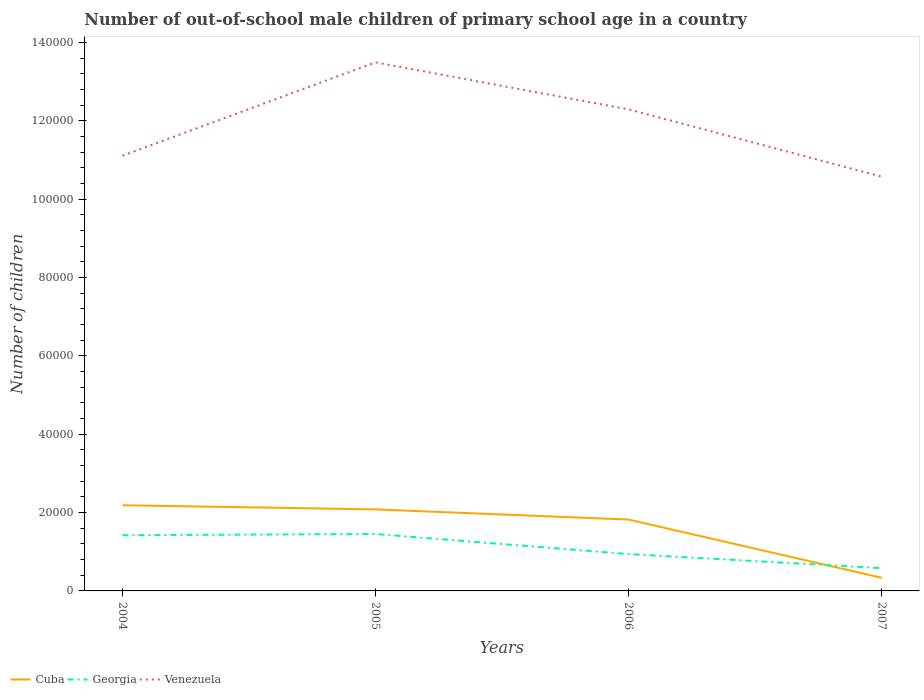Across all years, what is the maximum number of out-of-school male children in Venezuela?
Your answer should be very brief. 1.06e+05. In which year was the number of out-of-school male children in Georgia maximum?
Provide a short and direct response. 2007. What is the total number of out-of-school male children in Venezuela in the graph?
Provide a short and direct response. 1.72e+04. What is the difference between the highest and the second highest number of out-of-school male children in Cuba?
Keep it short and to the point. 1.85e+04. How many years are there in the graph?
Provide a succinct answer. 4. What is the difference between two consecutive major ticks on the Y-axis?
Make the answer very short. 2.00e+04. Does the graph contain any zero values?
Give a very brief answer. No. Does the graph contain grids?
Offer a terse response. No. How many legend labels are there?
Provide a succinct answer. 3. What is the title of the graph?
Keep it short and to the point. Number of out-of-school male children of primary school age in a country. What is the label or title of the X-axis?
Keep it short and to the point. Years. What is the label or title of the Y-axis?
Keep it short and to the point. Number of children. What is the Number of children of Cuba in 2004?
Give a very brief answer. 2.19e+04. What is the Number of children of Georgia in 2004?
Give a very brief answer. 1.42e+04. What is the Number of children in Venezuela in 2004?
Offer a terse response. 1.11e+05. What is the Number of children in Cuba in 2005?
Offer a terse response. 2.08e+04. What is the Number of children in Georgia in 2005?
Make the answer very short. 1.45e+04. What is the Number of children of Venezuela in 2005?
Your response must be concise. 1.35e+05. What is the Number of children of Cuba in 2006?
Offer a very short reply. 1.82e+04. What is the Number of children in Georgia in 2006?
Make the answer very short. 9409. What is the Number of children of Venezuela in 2006?
Make the answer very short. 1.23e+05. What is the Number of children of Cuba in 2007?
Your answer should be very brief. 3360. What is the Number of children of Georgia in 2007?
Make the answer very short. 5818. What is the Number of children of Venezuela in 2007?
Offer a terse response. 1.06e+05. Across all years, what is the maximum Number of children of Cuba?
Your answer should be very brief. 2.19e+04. Across all years, what is the maximum Number of children in Georgia?
Keep it short and to the point. 1.45e+04. Across all years, what is the maximum Number of children of Venezuela?
Make the answer very short. 1.35e+05. Across all years, what is the minimum Number of children in Cuba?
Provide a succinct answer. 3360. Across all years, what is the minimum Number of children in Georgia?
Provide a succinct answer. 5818. Across all years, what is the minimum Number of children in Venezuela?
Offer a very short reply. 1.06e+05. What is the total Number of children of Cuba in the graph?
Your response must be concise. 6.43e+04. What is the total Number of children in Georgia in the graph?
Make the answer very short. 4.40e+04. What is the total Number of children in Venezuela in the graph?
Provide a succinct answer. 4.75e+05. What is the difference between the Number of children of Cuba in 2004 and that in 2005?
Provide a short and direct response. 1065. What is the difference between the Number of children of Georgia in 2004 and that in 2005?
Provide a succinct answer. -311. What is the difference between the Number of children in Venezuela in 2004 and that in 2005?
Make the answer very short. -2.38e+04. What is the difference between the Number of children in Cuba in 2004 and that in 2006?
Keep it short and to the point. 3655. What is the difference between the Number of children in Georgia in 2004 and that in 2006?
Your response must be concise. 4809. What is the difference between the Number of children of Venezuela in 2004 and that in 2006?
Provide a succinct answer. -1.18e+04. What is the difference between the Number of children in Cuba in 2004 and that in 2007?
Offer a terse response. 1.85e+04. What is the difference between the Number of children of Georgia in 2004 and that in 2007?
Provide a short and direct response. 8400. What is the difference between the Number of children in Venezuela in 2004 and that in 2007?
Give a very brief answer. 5335. What is the difference between the Number of children of Cuba in 2005 and that in 2006?
Offer a terse response. 2590. What is the difference between the Number of children in Georgia in 2005 and that in 2006?
Your response must be concise. 5120. What is the difference between the Number of children in Venezuela in 2005 and that in 2006?
Ensure brevity in your answer.  1.20e+04. What is the difference between the Number of children of Cuba in 2005 and that in 2007?
Give a very brief answer. 1.74e+04. What is the difference between the Number of children in Georgia in 2005 and that in 2007?
Give a very brief answer. 8711. What is the difference between the Number of children of Venezuela in 2005 and that in 2007?
Offer a very short reply. 2.92e+04. What is the difference between the Number of children of Cuba in 2006 and that in 2007?
Provide a short and direct response. 1.49e+04. What is the difference between the Number of children of Georgia in 2006 and that in 2007?
Ensure brevity in your answer.  3591. What is the difference between the Number of children in Venezuela in 2006 and that in 2007?
Offer a terse response. 1.72e+04. What is the difference between the Number of children in Cuba in 2004 and the Number of children in Georgia in 2005?
Your answer should be very brief. 7345. What is the difference between the Number of children in Cuba in 2004 and the Number of children in Venezuela in 2005?
Your answer should be compact. -1.13e+05. What is the difference between the Number of children of Georgia in 2004 and the Number of children of Venezuela in 2005?
Keep it short and to the point. -1.21e+05. What is the difference between the Number of children in Cuba in 2004 and the Number of children in Georgia in 2006?
Offer a terse response. 1.25e+04. What is the difference between the Number of children in Cuba in 2004 and the Number of children in Venezuela in 2006?
Your answer should be very brief. -1.01e+05. What is the difference between the Number of children in Georgia in 2004 and the Number of children in Venezuela in 2006?
Provide a short and direct response. -1.09e+05. What is the difference between the Number of children of Cuba in 2004 and the Number of children of Georgia in 2007?
Make the answer very short. 1.61e+04. What is the difference between the Number of children in Cuba in 2004 and the Number of children in Venezuela in 2007?
Ensure brevity in your answer.  -8.39e+04. What is the difference between the Number of children in Georgia in 2004 and the Number of children in Venezuela in 2007?
Make the answer very short. -9.15e+04. What is the difference between the Number of children in Cuba in 2005 and the Number of children in Georgia in 2006?
Provide a short and direct response. 1.14e+04. What is the difference between the Number of children of Cuba in 2005 and the Number of children of Venezuela in 2006?
Keep it short and to the point. -1.02e+05. What is the difference between the Number of children of Georgia in 2005 and the Number of children of Venezuela in 2006?
Make the answer very short. -1.08e+05. What is the difference between the Number of children of Cuba in 2005 and the Number of children of Georgia in 2007?
Ensure brevity in your answer.  1.50e+04. What is the difference between the Number of children of Cuba in 2005 and the Number of children of Venezuela in 2007?
Your response must be concise. -8.49e+04. What is the difference between the Number of children of Georgia in 2005 and the Number of children of Venezuela in 2007?
Your answer should be compact. -9.12e+04. What is the difference between the Number of children in Cuba in 2006 and the Number of children in Georgia in 2007?
Make the answer very short. 1.24e+04. What is the difference between the Number of children in Cuba in 2006 and the Number of children in Venezuela in 2007?
Make the answer very short. -8.75e+04. What is the difference between the Number of children of Georgia in 2006 and the Number of children of Venezuela in 2007?
Offer a terse response. -9.63e+04. What is the average Number of children in Cuba per year?
Keep it short and to the point. 1.61e+04. What is the average Number of children of Georgia per year?
Provide a short and direct response. 1.10e+04. What is the average Number of children in Venezuela per year?
Your response must be concise. 1.19e+05. In the year 2004, what is the difference between the Number of children of Cuba and Number of children of Georgia?
Offer a very short reply. 7656. In the year 2004, what is the difference between the Number of children of Cuba and Number of children of Venezuela?
Keep it short and to the point. -8.92e+04. In the year 2004, what is the difference between the Number of children in Georgia and Number of children in Venezuela?
Offer a very short reply. -9.69e+04. In the year 2005, what is the difference between the Number of children in Cuba and Number of children in Georgia?
Make the answer very short. 6280. In the year 2005, what is the difference between the Number of children of Cuba and Number of children of Venezuela?
Give a very brief answer. -1.14e+05. In the year 2005, what is the difference between the Number of children of Georgia and Number of children of Venezuela?
Ensure brevity in your answer.  -1.20e+05. In the year 2006, what is the difference between the Number of children in Cuba and Number of children in Georgia?
Your answer should be very brief. 8810. In the year 2006, what is the difference between the Number of children in Cuba and Number of children in Venezuela?
Your answer should be very brief. -1.05e+05. In the year 2006, what is the difference between the Number of children of Georgia and Number of children of Venezuela?
Your answer should be very brief. -1.14e+05. In the year 2007, what is the difference between the Number of children of Cuba and Number of children of Georgia?
Give a very brief answer. -2458. In the year 2007, what is the difference between the Number of children in Cuba and Number of children in Venezuela?
Your answer should be compact. -1.02e+05. In the year 2007, what is the difference between the Number of children in Georgia and Number of children in Venezuela?
Give a very brief answer. -9.99e+04. What is the ratio of the Number of children in Cuba in 2004 to that in 2005?
Offer a terse response. 1.05. What is the ratio of the Number of children in Georgia in 2004 to that in 2005?
Ensure brevity in your answer.  0.98. What is the ratio of the Number of children in Venezuela in 2004 to that in 2005?
Your answer should be very brief. 0.82. What is the ratio of the Number of children of Cuba in 2004 to that in 2006?
Provide a succinct answer. 1.2. What is the ratio of the Number of children of Georgia in 2004 to that in 2006?
Give a very brief answer. 1.51. What is the ratio of the Number of children in Venezuela in 2004 to that in 2006?
Provide a short and direct response. 0.9. What is the ratio of the Number of children in Cuba in 2004 to that in 2007?
Make the answer very short. 6.51. What is the ratio of the Number of children of Georgia in 2004 to that in 2007?
Offer a terse response. 2.44. What is the ratio of the Number of children of Venezuela in 2004 to that in 2007?
Keep it short and to the point. 1.05. What is the ratio of the Number of children in Cuba in 2005 to that in 2006?
Provide a short and direct response. 1.14. What is the ratio of the Number of children of Georgia in 2005 to that in 2006?
Make the answer very short. 1.54. What is the ratio of the Number of children in Venezuela in 2005 to that in 2006?
Make the answer very short. 1.1. What is the ratio of the Number of children in Cuba in 2005 to that in 2007?
Ensure brevity in your answer.  6.19. What is the ratio of the Number of children of Georgia in 2005 to that in 2007?
Offer a very short reply. 2.5. What is the ratio of the Number of children in Venezuela in 2005 to that in 2007?
Your answer should be compact. 1.28. What is the ratio of the Number of children in Cuba in 2006 to that in 2007?
Ensure brevity in your answer.  5.42. What is the ratio of the Number of children of Georgia in 2006 to that in 2007?
Offer a very short reply. 1.62. What is the ratio of the Number of children of Venezuela in 2006 to that in 2007?
Provide a short and direct response. 1.16. What is the difference between the highest and the second highest Number of children in Cuba?
Ensure brevity in your answer.  1065. What is the difference between the highest and the second highest Number of children of Georgia?
Keep it short and to the point. 311. What is the difference between the highest and the second highest Number of children in Venezuela?
Your response must be concise. 1.20e+04. What is the difference between the highest and the lowest Number of children of Cuba?
Provide a succinct answer. 1.85e+04. What is the difference between the highest and the lowest Number of children of Georgia?
Offer a very short reply. 8711. What is the difference between the highest and the lowest Number of children in Venezuela?
Keep it short and to the point. 2.92e+04. 